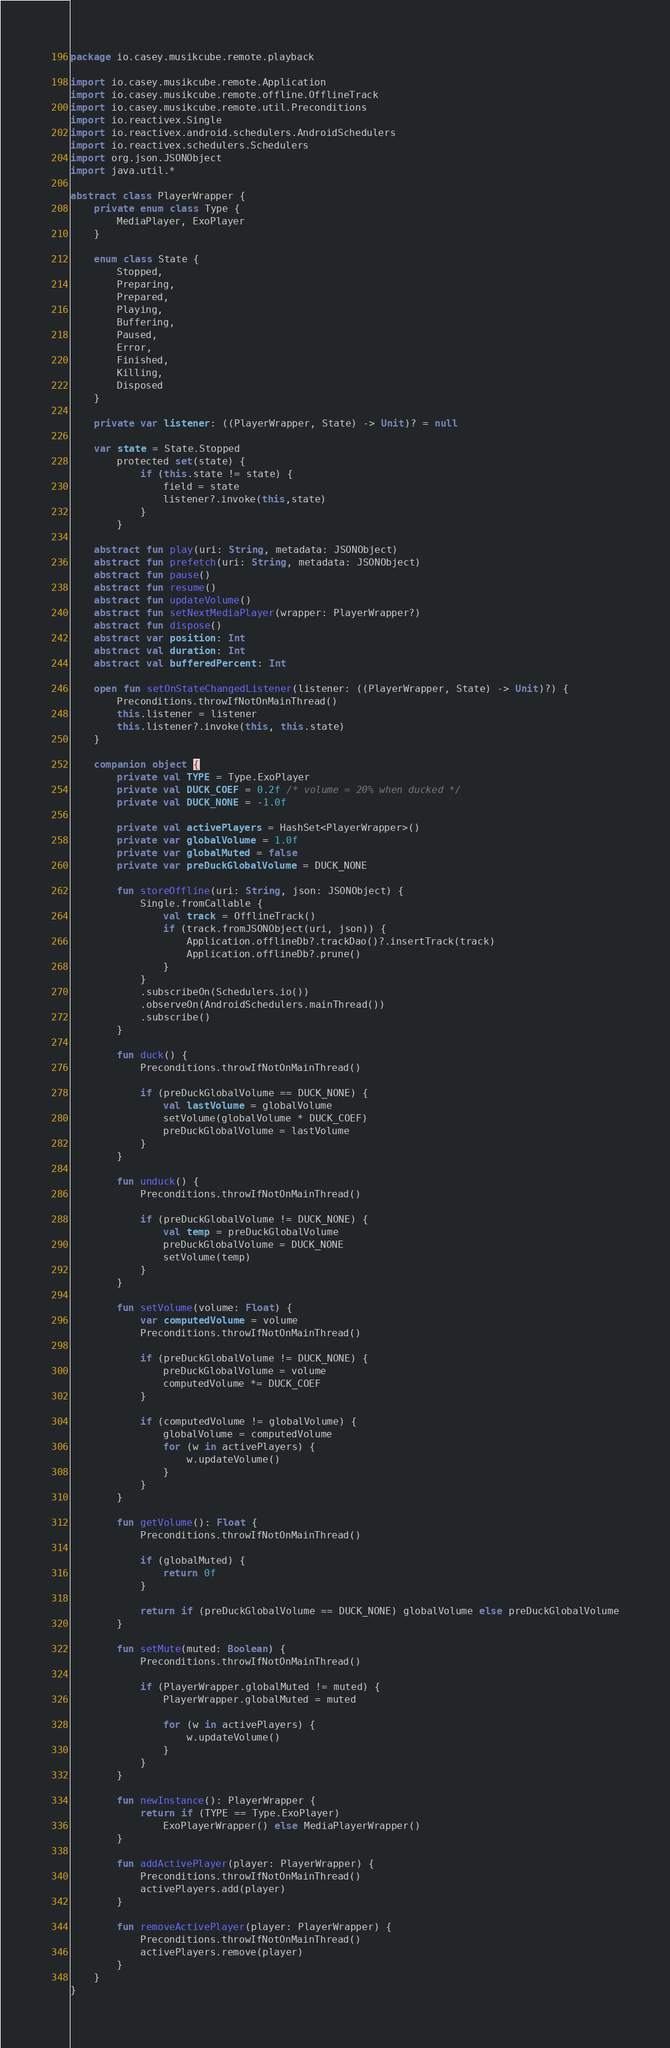Convert code to text. <code><loc_0><loc_0><loc_500><loc_500><_Kotlin_>package io.casey.musikcube.remote.playback

import io.casey.musikcube.remote.Application
import io.casey.musikcube.remote.offline.OfflineTrack
import io.casey.musikcube.remote.util.Preconditions
import io.reactivex.Single
import io.reactivex.android.schedulers.AndroidSchedulers
import io.reactivex.schedulers.Schedulers
import org.json.JSONObject
import java.util.*

abstract class PlayerWrapper {
    private enum class Type {
        MediaPlayer, ExoPlayer
    }

    enum class State {
        Stopped,
        Preparing,
        Prepared,
        Playing,
        Buffering,
        Paused,
        Error,
        Finished,
        Killing,
        Disposed
    }

    private var listener: ((PlayerWrapper, State) -> Unit)? = null

    var state = State.Stopped
        protected set(state) {
            if (this.state != state) {
                field = state
                listener?.invoke(this,state)
            }
        }

    abstract fun play(uri: String, metadata: JSONObject)
    abstract fun prefetch(uri: String, metadata: JSONObject)
    abstract fun pause()
    abstract fun resume()
    abstract fun updateVolume()
    abstract fun setNextMediaPlayer(wrapper: PlayerWrapper?)
    abstract fun dispose()
    abstract var position: Int
    abstract val duration: Int
    abstract val bufferedPercent: Int

    open fun setOnStateChangedListener(listener: ((PlayerWrapper, State) -> Unit)?) {
        Preconditions.throwIfNotOnMainThread()
        this.listener = listener
        this.listener?.invoke(this, this.state)
    }

    companion object {
        private val TYPE = Type.ExoPlayer
        private val DUCK_COEF = 0.2f /* volume = 20% when ducked */
        private val DUCK_NONE = -1.0f

        private val activePlayers = HashSet<PlayerWrapper>()
        private var globalVolume = 1.0f
        private var globalMuted = false
        private var preDuckGlobalVolume = DUCK_NONE

        fun storeOffline(uri: String, json: JSONObject) {
            Single.fromCallable {
                val track = OfflineTrack()
                if (track.fromJSONObject(uri, json)) {
                    Application.offlineDb?.trackDao()?.insertTrack(track)
                    Application.offlineDb?.prune()
                }
            }
            .subscribeOn(Schedulers.io())
            .observeOn(AndroidSchedulers.mainThread())
            .subscribe()
        }

        fun duck() {
            Preconditions.throwIfNotOnMainThread()

            if (preDuckGlobalVolume == DUCK_NONE) {
                val lastVolume = globalVolume
                setVolume(globalVolume * DUCK_COEF)
                preDuckGlobalVolume = lastVolume
            }
        }

        fun unduck() {
            Preconditions.throwIfNotOnMainThread()

            if (preDuckGlobalVolume != DUCK_NONE) {
                val temp = preDuckGlobalVolume
                preDuckGlobalVolume = DUCK_NONE
                setVolume(temp)
            }
        }

        fun setVolume(volume: Float) {
            var computedVolume = volume
            Preconditions.throwIfNotOnMainThread()

            if (preDuckGlobalVolume != DUCK_NONE) {
                preDuckGlobalVolume = volume
                computedVolume *= DUCK_COEF
            }

            if (computedVolume != globalVolume) {
                globalVolume = computedVolume
                for (w in activePlayers) {
                    w.updateVolume()
                }
            }
        }

        fun getVolume(): Float {
            Preconditions.throwIfNotOnMainThread()

            if (globalMuted) {
                return 0f
            }

            return if (preDuckGlobalVolume == DUCK_NONE) globalVolume else preDuckGlobalVolume
        }

        fun setMute(muted: Boolean) {
            Preconditions.throwIfNotOnMainThread()

            if (PlayerWrapper.globalMuted != muted) {
                PlayerWrapper.globalMuted = muted

                for (w in activePlayers) {
                    w.updateVolume()
                }
            }
        }

        fun newInstance(): PlayerWrapper {
            return if (TYPE == Type.ExoPlayer)
                ExoPlayerWrapper() else MediaPlayerWrapper()
        }

        fun addActivePlayer(player: PlayerWrapper) {
            Preconditions.throwIfNotOnMainThread()
            activePlayers.add(player)
        }

        fun removeActivePlayer(player: PlayerWrapper) {
            Preconditions.throwIfNotOnMainThread()
            activePlayers.remove(player)
        }
    }
}
</code> 